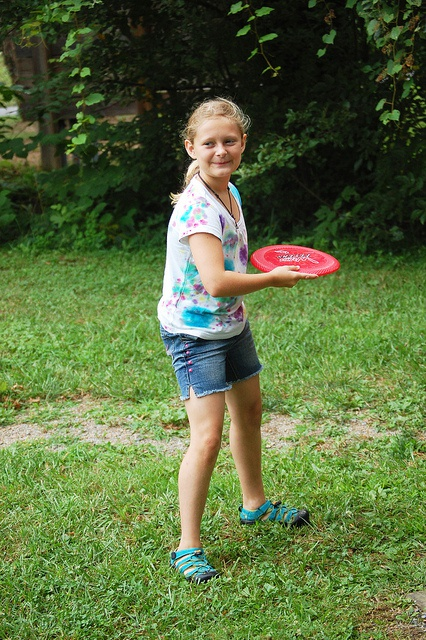Describe the objects in this image and their specific colors. I can see people in black, lightgray, olive, and tan tones and frisbee in black, salmon, lightpink, and red tones in this image. 